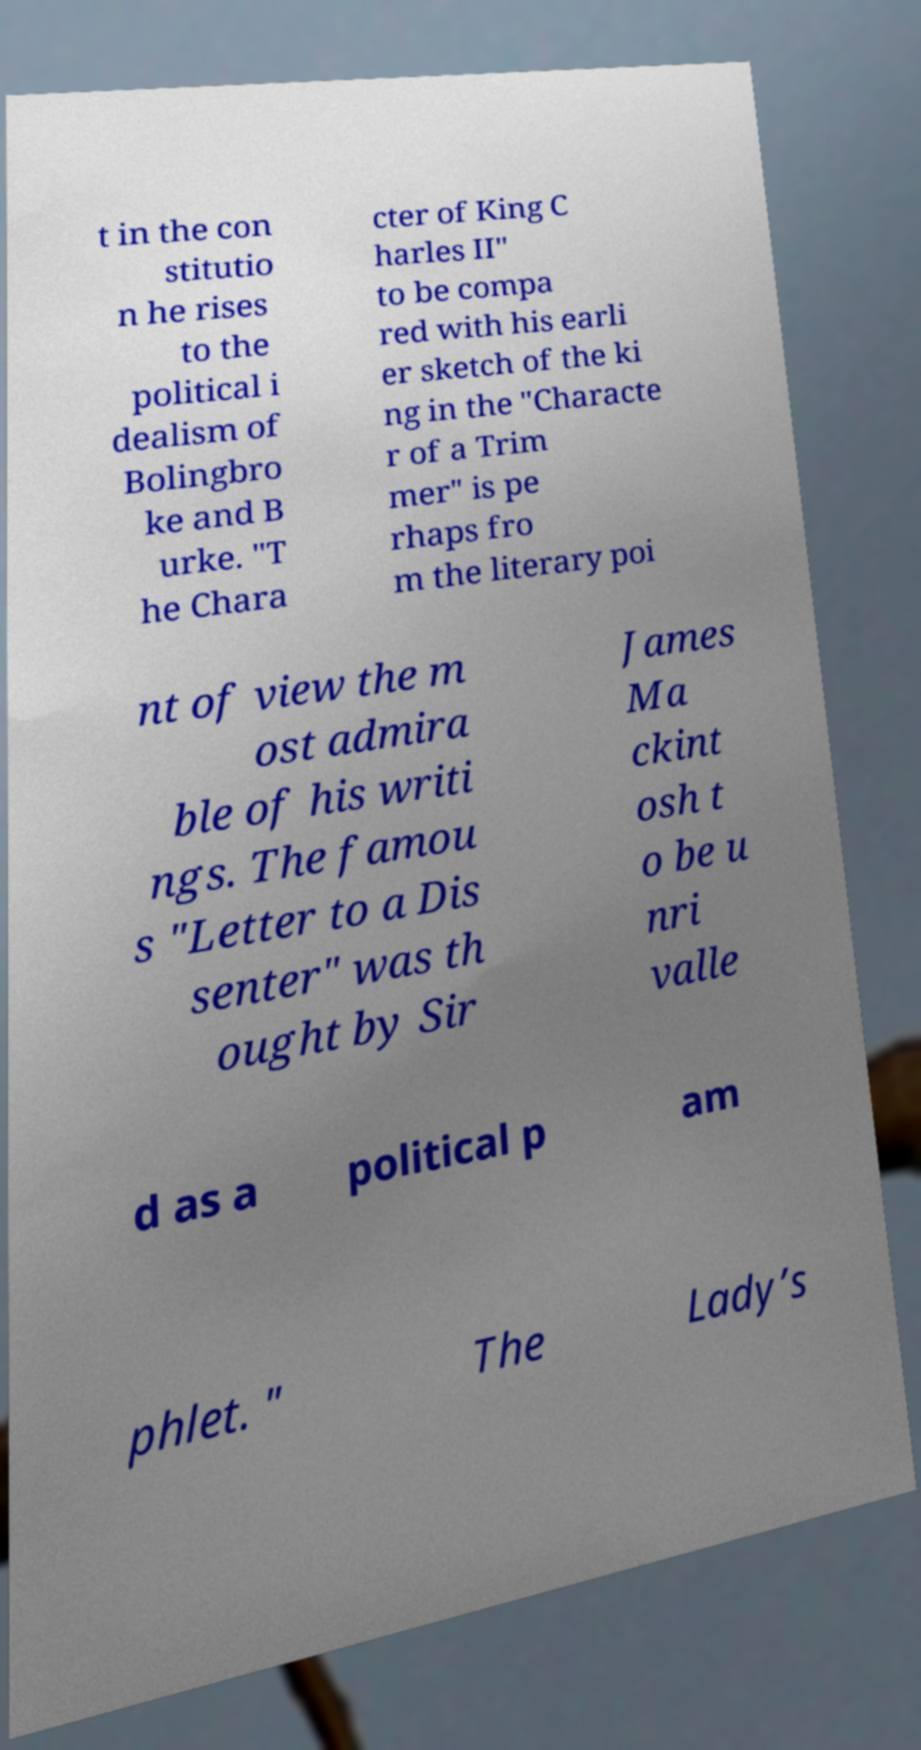For documentation purposes, I need the text within this image transcribed. Could you provide that? t in the con stitutio n he rises to the political i dealism of Bolingbro ke and B urke. "T he Chara cter of King C harles II" to be compa red with his earli er sketch of the ki ng in the "Characte r of a Trim mer" is pe rhaps fro m the literary poi nt of view the m ost admira ble of his writi ngs. The famou s "Letter to a Dis senter" was th ought by Sir James Ma ckint osh t o be u nri valle d as a political p am phlet. " The Lady’s 